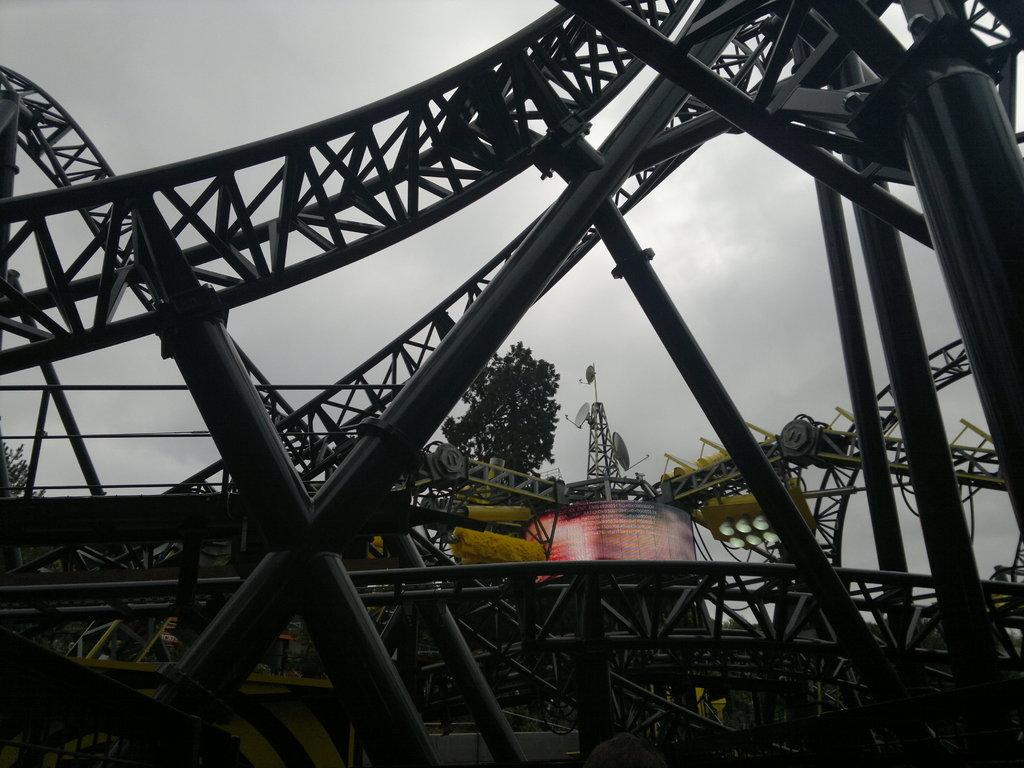What is the main subject of the image? The main subject of the image is a roller coaster. Are there any other structures or objects visible in the image? Yes, there is a tower with antennas in the image. What type of natural elements can be seen in the image? Trees are visible in the image. What is visible in the background of the image? The sky is visible in the background of the image. What color is the daughter's scarf in the image? There is no daughter or scarf present in the image. Where is the daughter wearing the scarf in the image? There is no daughter or scarf present in the image, so it is not possible to determine where a daughter might be wearing a scarf. 